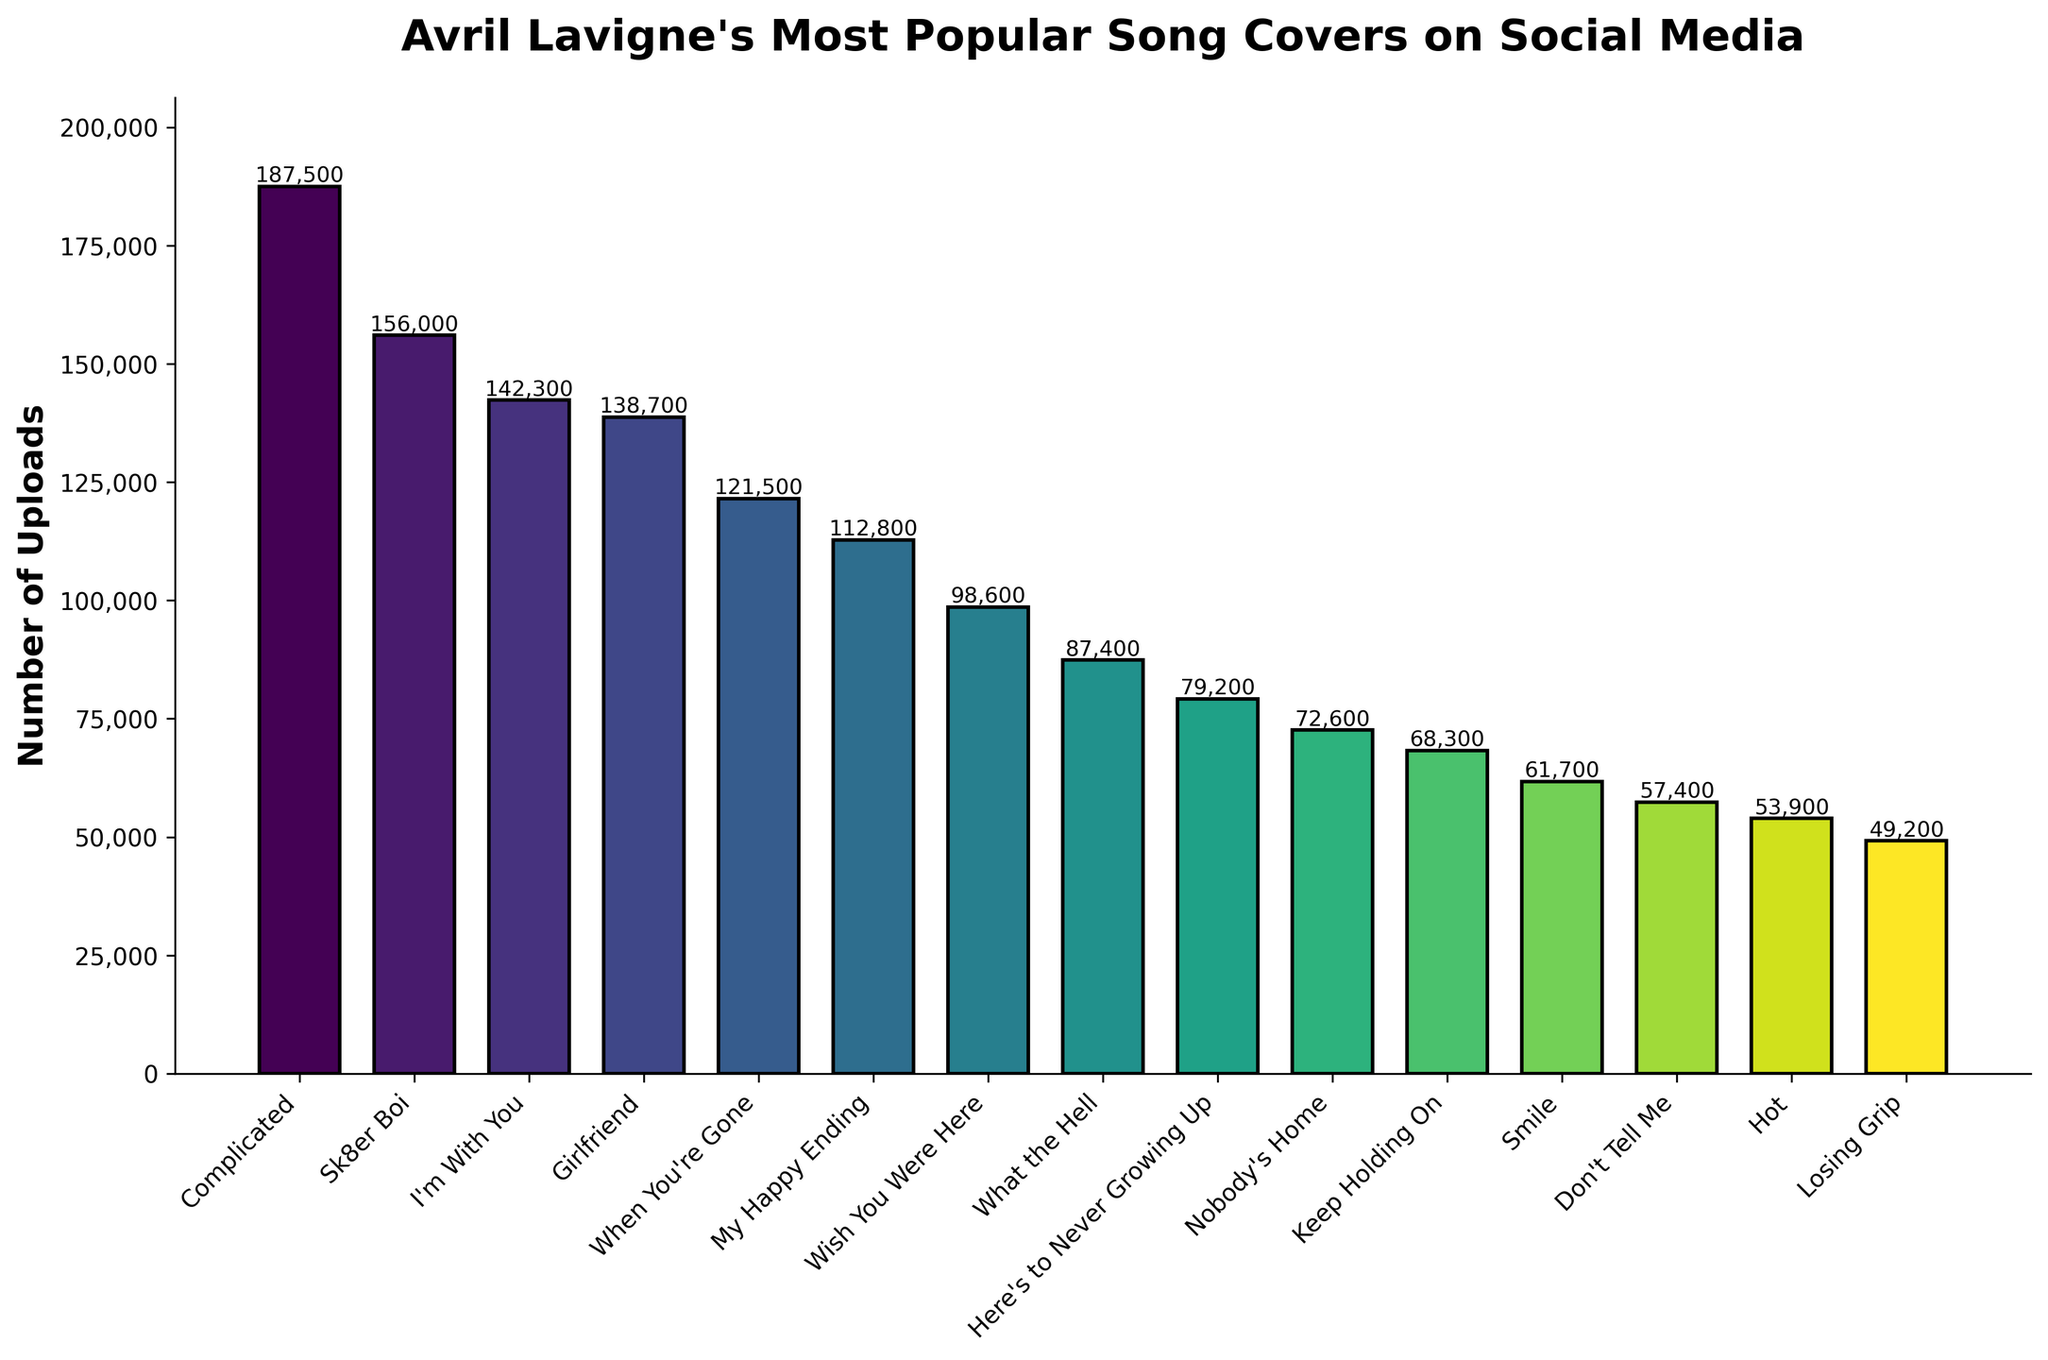What's the most popular Avril Lavigne song cover on social media platforms by number of uploads? The highest bar represents the song with the most uploads. The tallest bar corresponds to "Complicated" with 187,500 uploads.
Answer: Complicated How many more uploads does "Sk8er Boi" have compared to "Losing Grip"? "Sk8er Boi" has 156,000 uploads, and "Losing Grip" has 49,200 uploads. The difference is 156,000 - 49,200.
Answer: 106,800 What's the total number of uploads for the top three most popular songs? The number of uploads for "Complicated" is 187,500, for "Sk8er Boi" is 156,000, and for "I'm With You" is 142,300. Sum these values: 187,500 + 156,000 + 142,300.
Answer: 485,800 How does the number of uploads for "Girlfriend" compare to "What the Hell"? "Girlfriend" has 138,700 uploads, and "What the Hell" has 87,400 uploads. 138,700 is greater than 87,400.
Answer: Girlfriend has more uploads Which song has fewer uploads than "Here's to Never Growing Up" but more than "Hot"? "Nobody's Home" has 72,600 uploads, which is fewer than "Here's to Never Growing Up" with 79,200 uploads, and more than "Hot" with 53,900 uploads.
Answer: Nobody's Home What's the average number of uploads for the bottom five songs in terms of popularity? The bottom five songs are "Smile" (61,700), "Don't Tell Me" (57,400), "Hot" (53,900), and "Losing Grip" (49,200). Sum these values and divide by the number of songs: (61,700 + 57,400 + 53,900 + 49,200) / 4.
Answer: 55,050 Which song title is associated with the fourth tallest bar in the chart, and how many uploads does it have? The fourth tallest bar corresponds to "Girlfriend," which has 138,700 uploads.
Answer: Girlfriend, 138,700 How many songs have over 100,000 uploads? The songs over 100,000 uploads are "Complicated," "Sk8er Boi," "I'm With You," "Girlfriend," "When You're Gone," and "My Happy Ending." There are six such songs.
Answer: 6 